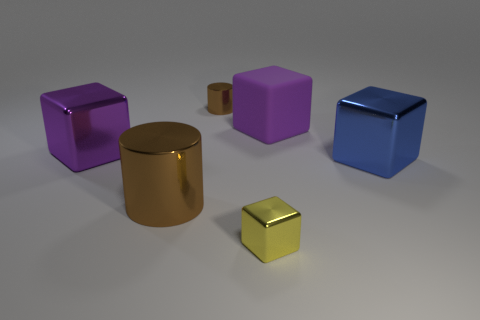Are there fewer big shiny cubes that are to the right of the small yellow metallic block than tiny cubes behind the large blue thing?
Keep it short and to the point. No. The other object that is the same shape as the small brown shiny object is what color?
Your answer should be very brief. Brown. What number of large metallic objects are both right of the big brown thing and left of the blue block?
Make the answer very short. 0. Is the number of purple objects behind the yellow object greater than the number of brown things that are to the left of the big brown metallic cylinder?
Offer a terse response. Yes. The purple rubber object has what size?
Your answer should be very brief. Large. Are there any large purple shiny objects that have the same shape as the yellow thing?
Keep it short and to the point. Yes. Do the small yellow thing and the big metallic thing that is behind the large blue metal cube have the same shape?
Ensure brevity in your answer.  Yes. There is a thing that is both in front of the large blue metal thing and left of the small yellow cube; what is its size?
Your answer should be very brief. Large. What number of small shiny objects are there?
Give a very brief answer. 2. What material is the brown thing that is the same size as the purple shiny object?
Your answer should be very brief. Metal. 